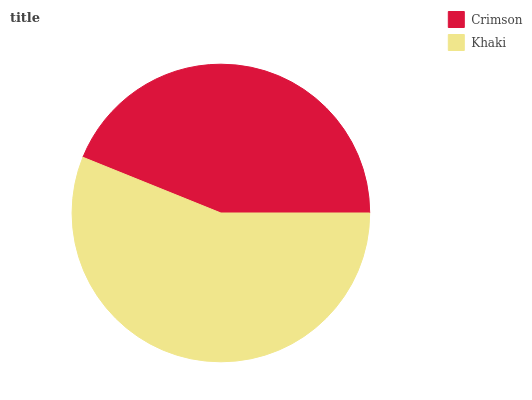Is Crimson the minimum?
Answer yes or no. Yes. Is Khaki the maximum?
Answer yes or no. Yes. Is Khaki the minimum?
Answer yes or no. No. Is Khaki greater than Crimson?
Answer yes or no. Yes. Is Crimson less than Khaki?
Answer yes or no. Yes. Is Crimson greater than Khaki?
Answer yes or no. No. Is Khaki less than Crimson?
Answer yes or no. No. Is Khaki the high median?
Answer yes or no. Yes. Is Crimson the low median?
Answer yes or no. Yes. Is Crimson the high median?
Answer yes or no. No. Is Khaki the low median?
Answer yes or no. No. 